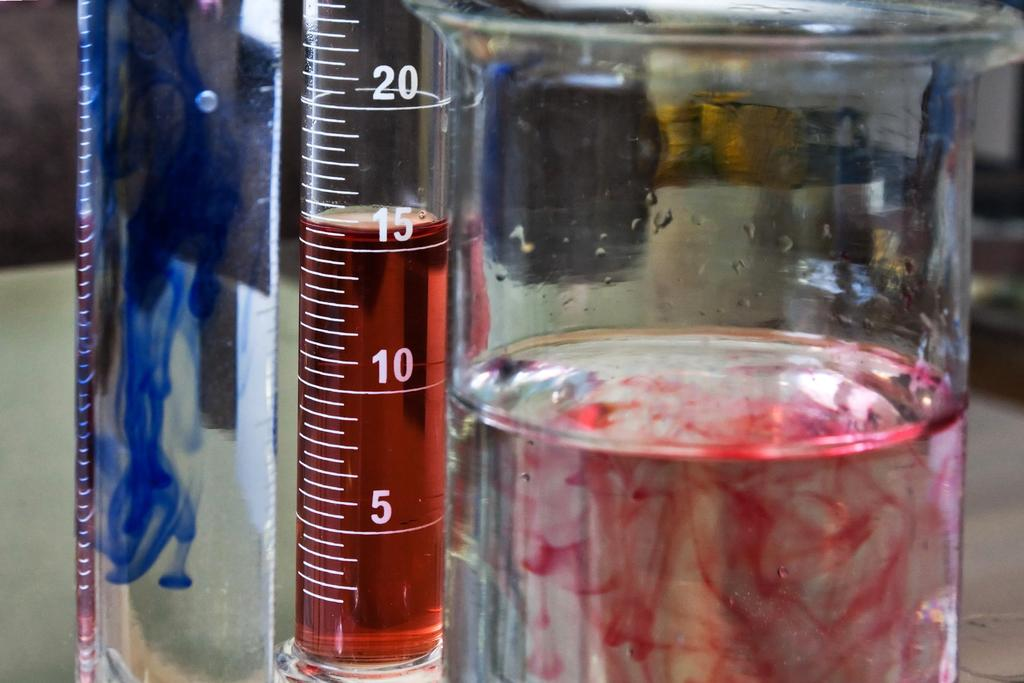<image>
Share a concise interpretation of the image provided. A test tube has red liquid in it up to the number 15. 